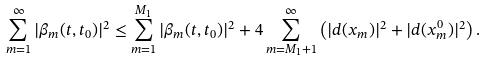Convert formula to latex. <formula><loc_0><loc_0><loc_500><loc_500>\sum _ { m = 1 } ^ { \infty } | \beta _ { m } ( t , t _ { 0 } ) | ^ { 2 } \leq \sum _ { m = 1 } ^ { M _ { 1 } } | \beta _ { m } ( t , t _ { 0 } ) | ^ { 2 } + 4 \sum _ { m = M _ { 1 } + 1 } ^ { \infty } \left ( | d ( x _ { m } ) | ^ { 2 } + | d ( x ^ { 0 } _ { m } ) | ^ { 2 } \right ) .</formula> 